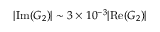Convert formula to latex. <formula><loc_0><loc_0><loc_500><loc_500>| I m ( G _ { 2 } ) | \sim 3 \times 1 0 ^ { - 3 } | R e ( G _ { 2 } ) |</formula> 